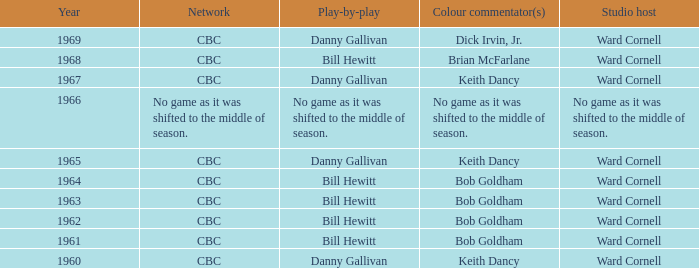Who did the play-by-play on the CBC network before 1961? Danny Gallivan. 